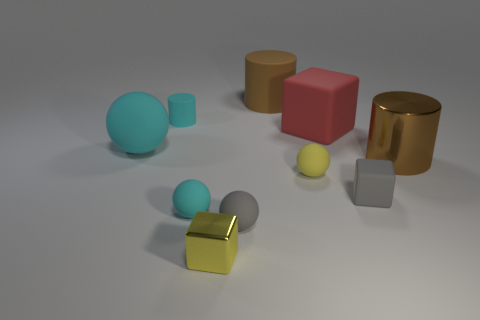Is there a rubber object of the same color as the tiny cylinder?
Provide a succinct answer. Yes. There is a matte cylinder that is the same color as the metallic cylinder; what is its size?
Keep it short and to the point. Large. Do the yellow thing that is to the left of the gray matte ball and the brown object behind the big cyan thing have the same size?
Give a very brief answer. No. There is a yellow object that is behind the small gray matte block; what size is it?
Offer a terse response. Small. There is another large cylinder that is the same color as the large metal cylinder; what is its material?
Provide a succinct answer. Rubber. There is a metallic thing that is the same size as the cyan rubber cylinder; what color is it?
Offer a very short reply. Yellow. Is the cyan cylinder the same size as the yellow metal block?
Your response must be concise. Yes. There is a block that is both right of the small yellow shiny thing and in front of the large red matte block; what size is it?
Your response must be concise. Small. What number of metal things are either gray objects or tiny cyan things?
Give a very brief answer. 0. Are there more objects that are to the right of the red block than small gray objects?
Provide a short and direct response. No. 